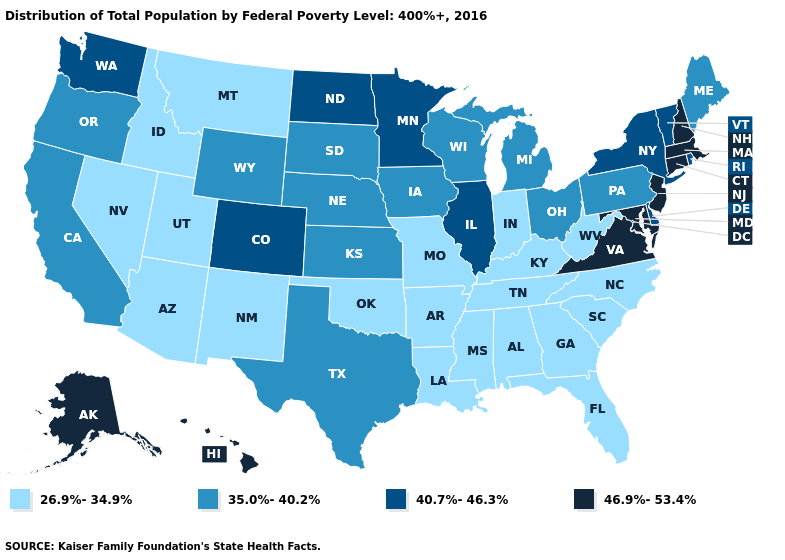How many symbols are there in the legend?
Give a very brief answer. 4. What is the lowest value in the West?
Give a very brief answer. 26.9%-34.9%. Name the states that have a value in the range 40.7%-46.3%?
Concise answer only. Colorado, Delaware, Illinois, Minnesota, New York, North Dakota, Rhode Island, Vermont, Washington. Name the states that have a value in the range 35.0%-40.2%?
Quick response, please. California, Iowa, Kansas, Maine, Michigan, Nebraska, Ohio, Oregon, Pennsylvania, South Dakota, Texas, Wisconsin, Wyoming. Does Michigan have a higher value than Louisiana?
Be succinct. Yes. Among the states that border Massachusetts , does New Hampshire have the lowest value?
Concise answer only. No. What is the value of Arizona?
Answer briefly. 26.9%-34.9%. Does Alaska have the lowest value in the USA?
Give a very brief answer. No. What is the value of Florida?
Quick response, please. 26.9%-34.9%. What is the lowest value in states that border Ohio?
Give a very brief answer. 26.9%-34.9%. What is the value of Maine?
Give a very brief answer. 35.0%-40.2%. What is the value of Florida?
Give a very brief answer. 26.9%-34.9%. What is the highest value in the USA?
Be succinct. 46.9%-53.4%. Which states have the lowest value in the USA?
Answer briefly. Alabama, Arizona, Arkansas, Florida, Georgia, Idaho, Indiana, Kentucky, Louisiana, Mississippi, Missouri, Montana, Nevada, New Mexico, North Carolina, Oklahoma, South Carolina, Tennessee, Utah, West Virginia. 